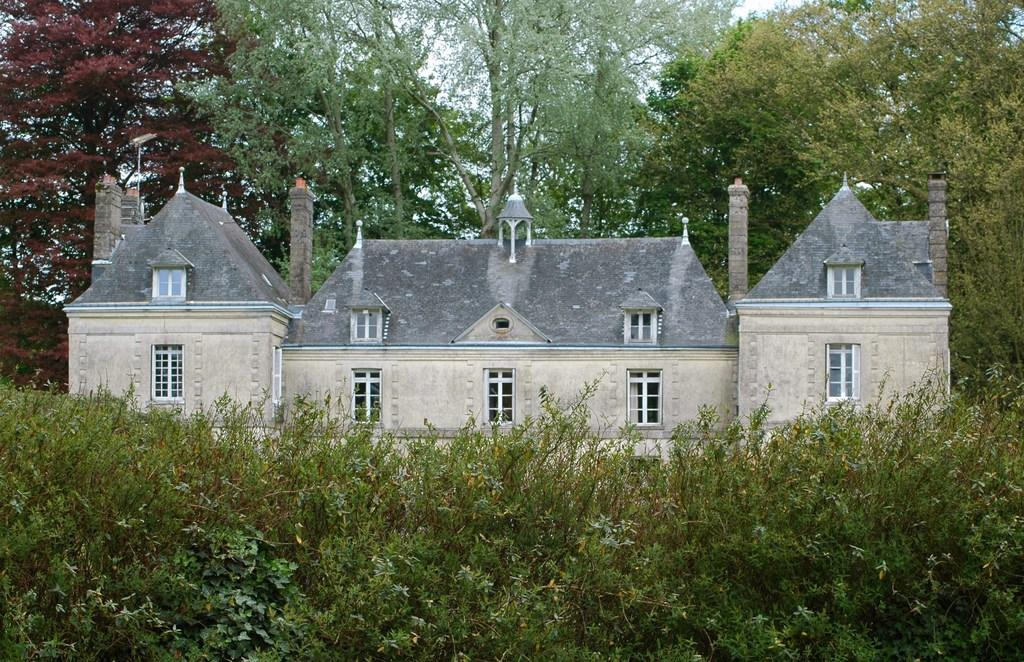What is the main structure in the center of the image? There is a house in the center of the image. What can be seen at the bottom of the image? There are plants at the bottom of the image. What is visible in the background of the image? There are trees and poles in the background of the image. What type of coil is used to create the boundary around the house in the image? There is no coil or boundary visible around the house in the image. How many rooms can be seen in the house in the image? The image does not show the interior of the house, so it is not possible to determine the number of rooms. 